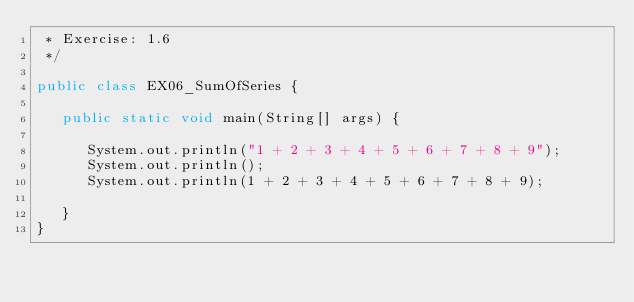Convert code to text. <code><loc_0><loc_0><loc_500><loc_500><_Java_> * Exercise: 1.6
 */
 
public class EX06_SumOfSeries {
 
   public static void main(String[] args) {
   
      System.out.println("1 + 2 + 3 + 4 + 5 + 6 + 7 + 8 + 9");
      System.out.println();
      System.out.println(1 + 2 + 3 + 4 + 5 + 6 + 7 + 8 + 9);
   
   }
}
</code> 